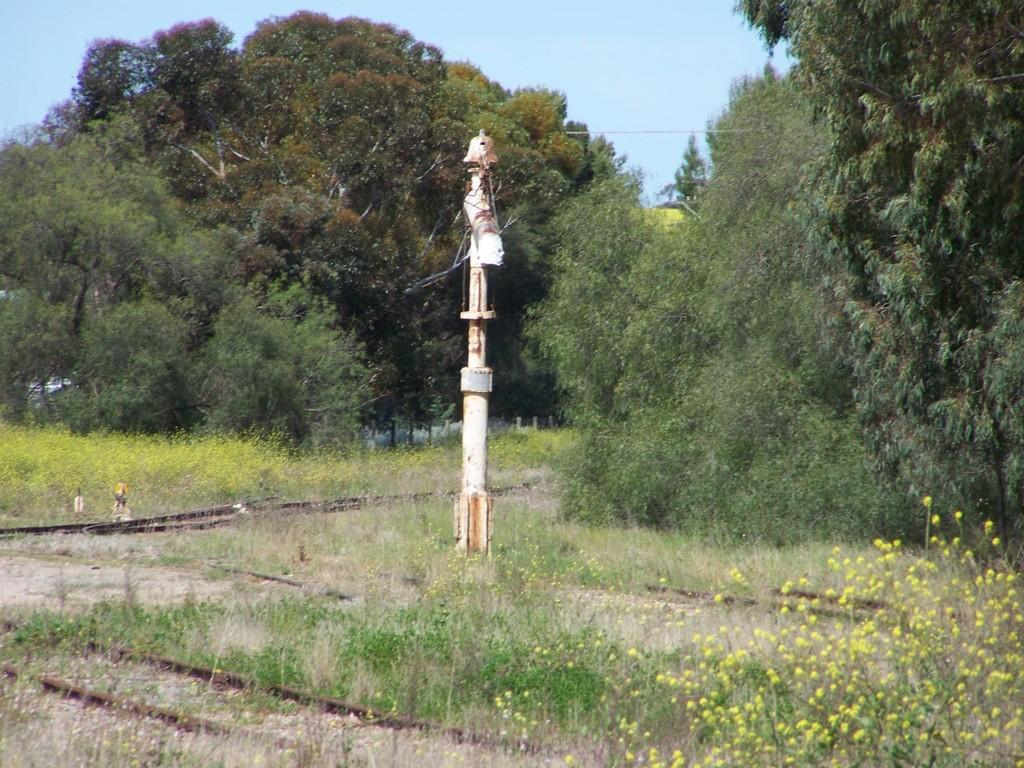What type of vegetation is present in the image? There is grass and plants with flowers in the image. Can you describe the plants with flowers? The plants with flowers are not specified, but they are present in the image. What else can be seen in the image besides vegetation? There is a pole in the image. What is visible in the background of the image? There are trees and the sky visible in the background of the image. What type of zinc material is used to construct the building in the image? There is no building present in the image, so it is not possible to determine the type of zinc material used in its construction. --- Facts: 1. There is a person in the image. 2. The person is holding a book. 3. The person is sitting on a chair. 4. There is a table in the image. 5. The table has a lamp on it. Absurd Topics: elephant, ocean, bicycle Conversation: What is the person in the image doing? The person in the image is holding a book. Where is the person sitting in the image? The person is sitting on a chair. What else can be seen in the image besides the person? There is a table in the image, and the table has a lamp on it. Reasoning: Let's think step by step in order to produce the conversation. We start by identifying the main subject in the image, which is the person holding a book. Then, we expand the conversation to include other items that are also visible, such as the chair, table, and lamp. Each question is designed to elicit a specific detail about the image that is known from the provided facts. Absurd Question/Answer: Can you describe the elephant swimming in the ocean in the image? There is no elephant or ocean present in the image; it features a person holding a book and sitting on a chair with a table and lamp nearby. 